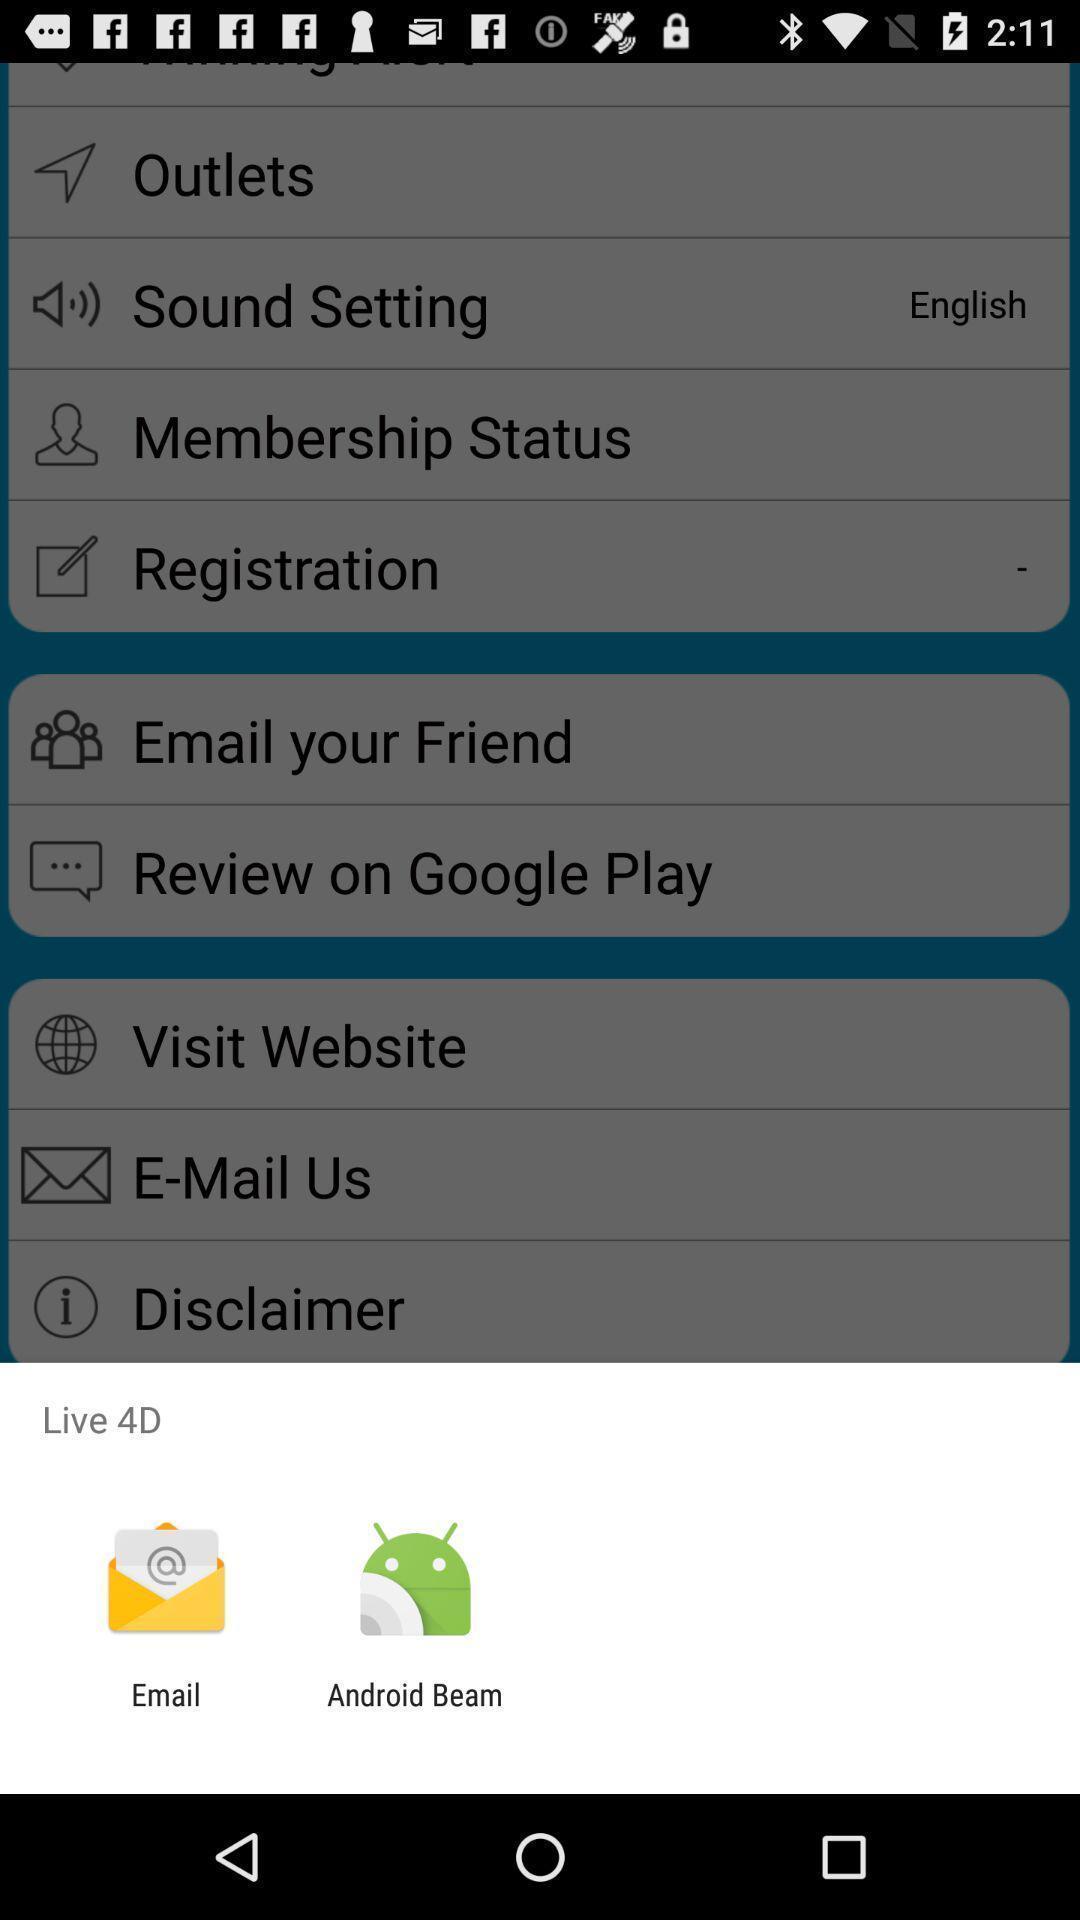What can you discern from this picture? Widget displaying two data sharing apps. 